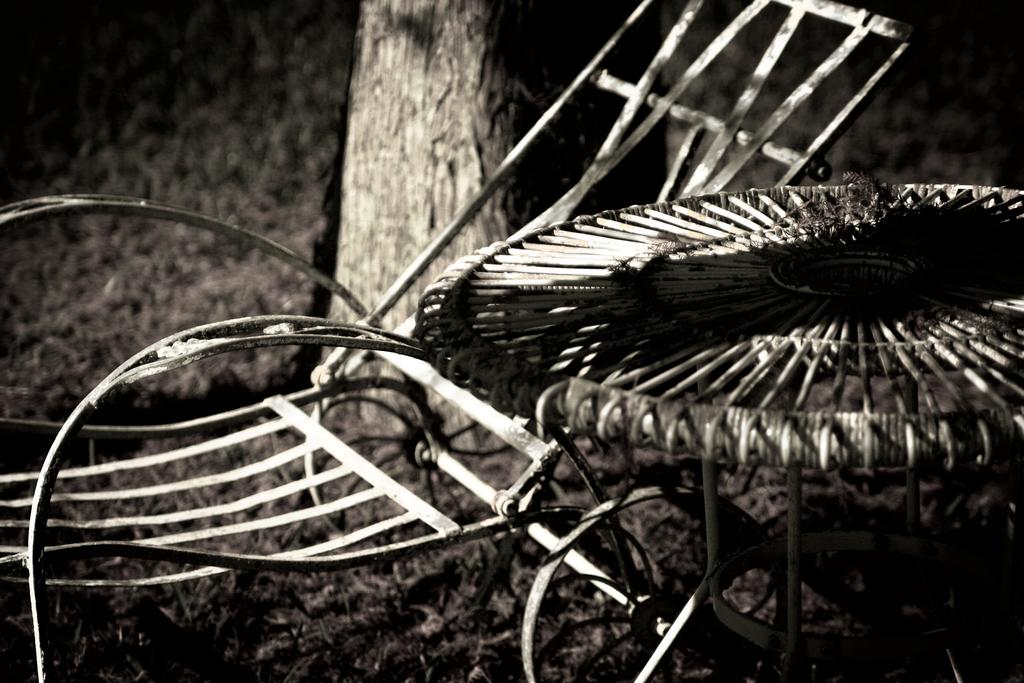What is the color scheme of the image? The image is black and white. What type of furniture is present in the image? There is a chair in the image. What other object can be seen in the image? There is a table in the image. What natural element is visible in the image? There is a tree in the image. What type of ground surface is present in the image? There is grass on the ground in the image. How many houses are visible in the image? There are no houses visible in the image; it features a chair, table, tree, and grass. What type of lamp is present on the table in the image? There is no lamp present on the table in the image. 